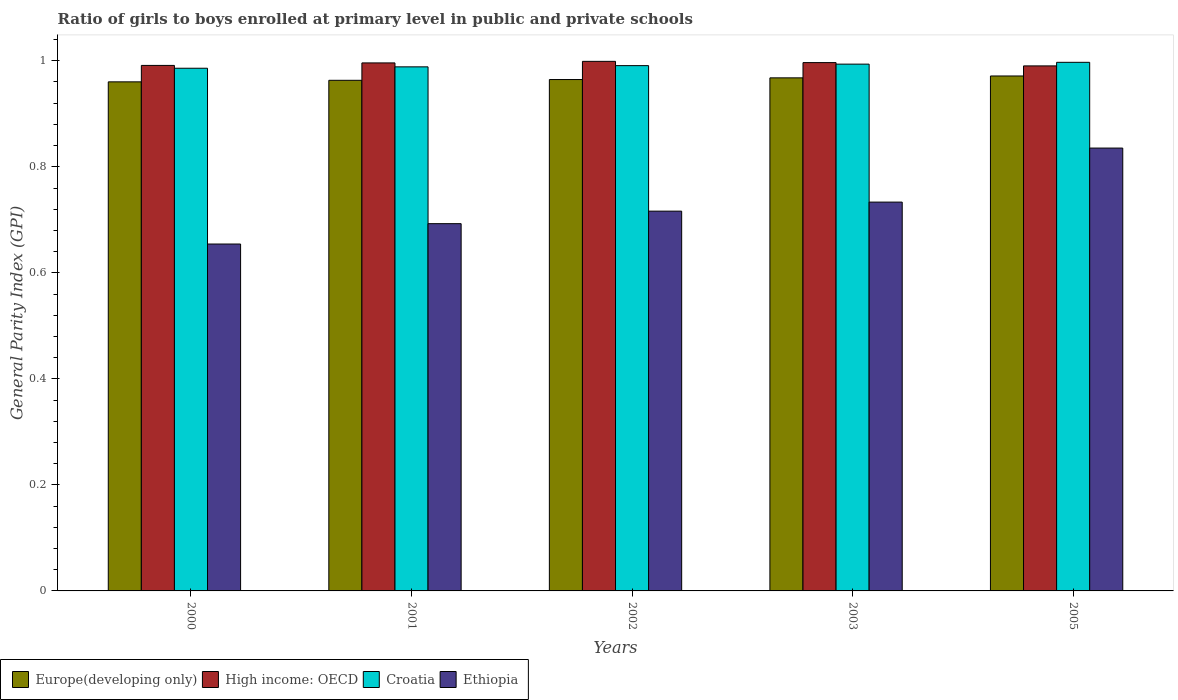Are the number of bars per tick equal to the number of legend labels?
Make the answer very short. Yes. What is the general parity index in Europe(developing only) in 2005?
Your answer should be compact. 0.97. Across all years, what is the maximum general parity index in High income: OECD?
Provide a succinct answer. 1. Across all years, what is the minimum general parity index in Croatia?
Your response must be concise. 0.99. What is the total general parity index in Europe(developing only) in the graph?
Provide a succinct answer. 4.83. What is the difference between the general parity index in Ethiopia in 2001 and that in 2002?
Your answer should be very brief. -0.02. What is the difference between the general parity index in High income: OECD in 2003 and the general parity index in Europe(developing only) in 2002?
Give a very brief answer. 0.03. What is the average general parity index in Ethiopia per year?
Offer a very short reply. 0.73. In the year 2001, what is the difference between the general parity index in Ethiopia and general parity index in High income: OECD?
Your answer should be compact. -0.3. What is the ratio of the general parity index in High income: OECD in 2001 to that in 2003?
Make the answer very short. 1. Is the general parity index in Croatia in 2000 less than that in 2002?
Ensure brevity in your answer.  Yes. What is the difference between the highest and the second highest general parity index in Croatia?
Offer a very short reply. 0. What is the difference between the highest and the lowest general parity index in Europe(developing only)?
Keep it short and to the point. 0.01. In how many years, is the general parity index in Ethiopia greater than the average general parity index in Ethiopia taken over all years?
Provide a short and direct response. 2. Is it the case that in every year, the sum of the general parity index in High income: OECD and general parity index in Europe(developing only) is greater than the sum of general parity index in Croatia and general parity index in Ethiopia?
Your answer should be very brief. No. What does the 1st bar from the left in 2002 represents?
Give a very brief answer. Europe(developing only). What does the 2nd bar from the right in 2005 represents?
Give a very brief answer. Croatia. How many bars are there?
Your response must be concise. 20. Are all the bars in the graph horizontal?
Offer a terse response. No. How many years are there in the graph?
Provide a short and direct response. 5. What is the difference between two consecutive major ticks on the Y-axis?
Ensure brevity in your answer.  0.2. Does the graph contain any zero values?
Keep it short and to the point. No. Does the graph contain grids?
Ensure brevity in your answer.  No. How many legend labels are there?
Your answer should be compact. 4. How are the legend labels stacked?
Your answer should be very brief. Horizontal. What is the title of the graph?
Your response must be concise. Ratio of girls to boys enrolled at primary level in public and private schools. What is the label or title of the X-axis?
Ensure brevity in your answer.  Years. What is the label or title of the Y-axis?
Offer a very short reply. General Parity Index (GPI). What is the General Parity Index (GPI) of Europe(developing only) in 2000?
Offer a very short reply. 0.96. What is the General Parity Index (GPI) of High income: OECD in 2000?
Provide a short and direct response. 0.99. What is the General Parity Index (GPI) in Croatia in 2000?
Give a very brief answer. 0.99. What is the General Parity Index (GPI) in Ethiopia in 2000?
Your response must be concise. 0.65. What is the General Parity Index (GPI) in Europe(developing only) in 2001?
Provide a short and direct response. 0.96. What is the General Parity Index (GPI) of High income: OECD in 2001?
Offer a very short reply. 1. What is the General Parity Index (GPI) in Croatia in 2001?
Your answer should be compact. 0.99. What is the General Parity Index (GPI) in Ethiopia in 2001?
Provide a succinct answer. 0.69. What is the General Parity Index (GPI) in Europe(developing only) in 2002?
Your answer should be very brief. 0.96. What is the General Parity Index (GPI) in High income: OECD in 2002?
Give a very brief answer. 1. What is the General Parity Index (GPI) in Croatia in 2002?
Provide a short and direct response. 0.99. What is the General Parity Index (GPI) in Ethiopia in 2002?
Keep it short and to the point. 0.72. What is the General Parity Index (GPI) of Europe(developing only) in 2003?
Make the answer very short. 0.97. What is the General Parity Index (GPI) of High income: OECD in 2003?
Keep it short and to the point. 1. What is the General Parity Index (GPI) in Croatia in 2003?
Offer a very short reply. 0.99. What is the General Parity Index (GPI) of Ethiopia in 2003?
Offer a very short reply. 0.73. What is the General Parity Index (GPI) of Europe(developing only) in 2005?
Offer a terse response. 0.97. What is the General Parity Index (GPI) in High income: OECD in 2005?
Provide a succinct answer. 0.99. What is the General Parity Index (GPI) of Croatia in 2005?
Offer a terse response. 1. What is the General Parity Index (GPI) of Ethiopia in 2005?
Keep it short and to the point. 0.84. Across all years, what is the maximum General Parity Index (GPI) in Europe(developing only)?
Your response must be concise. 0.97. Across all years, what is the maximum General Parity Index (GPI) in High income: OECD?
Offer a terse response. 1. Across all years, what is the maximum General Parity Index (GPI) in Croatia?
Provide a succinct answer. 1. Across all years, what is the maximum General Parity Index (GPI) of Ethiopia?
Provide a short and direct response. 0.84. Across all years, what is the minimum General Parity Index (GPI) in Europe(developing only)?
Your answer should be very brief. 0.96. Across all years, what is the minimum General Parity Index (GPI) in High income: OECD?
Provide a succinct answer. 0.99. Across all years, what is the minimum General Parity Index (GPI) of Croatia?
Offer a terse response. 0.99. Across all years, what is the minimum General Parity Index (GPI) of Ethiopia?
Offer a very short reply. 0.65. What is the total General Parity Index (GPI) in Europe(developing only) in the graph?
Provide a short and direct response. 4.83. What is the total General Parity Index (GPI) of High income: OECD in the graph?
Your answer should be very brief. 4.97. What is the total General Parity Index (GPI) in Croatia in the graph?
Your response must be concise. 4.96. What is the total General Parity Index (GPI) in Ethiopia in the graph?
Ensure brevity in your answer.  3.63. What is the difference between the General Parity Index (GPI) in Europe(developing only) in 2000 and that in 2001?
Your response must be concise. -0. What is the difference between the General Parity Index (GPI) of High income: OECD in 2000 and that in 2001?
Your answer should be very brief. -0. What is the difference between the General Parity Index (GPI) in Croatia in 2000 and that in 2001?
Provide a succinct answer. -0. What is the difference between the General Parity Index (GPI) of Ethiopia in 2000 and that in 2001?
Provide a succinct answer. -0.04. What is the difference between the General Parity Index (GPI) of Europe(developing only) in 2000 and that in 2002?
Make the answer very short. -0. What is the difference between the General Parity Index (GPI) in High income: OECD in 2000 and that in 2002?
Make the answer very short. -0.01. What is the difference between the General Parity Index (GPI) of Croatia in 2000 and that in 2002?
Your answer should be compact. -0. What is the difference between the General Parity Index (GPI) in Ethiopia in 2000 and that in 2002?
Make the answer very short. -0.06. What is the difference between the General Parity Index (GPI) in Europe(developing only) in 2000 and that in 2003?
Make the answer very short. -0.01. What is the difference between the General Parity Index (GPI) in High income: OECD in 2000 and that in 2003?
Provide a short and direct response. -0.01. What is the difference between the General Parity Index (GPI) in Croatia in 2000 and that in 2003?
Ensure brevity in your answer.  -0.01. What is the difference between the General Parity Index (GPI) in Ethiopia in 2000 and that in 2003?
Your answer should be very brief. -0.08. What is the difference between the General Parity Index (GPI) of Europe(developing only) in 2000 and that in 2005?
Keep it short and to the point. -0.01. What is the difference between the General Parity Index (GPI) in High income: OECD in 2000 and that in 2005?
Your response must be concise. 0. What is the difference between the General Parity Index (GPI) of Croatia in 2000 and that in 2005?
Ensure brevity in your answer.  -0.01. What is the difference between the General Parity Index (GPI) of Ethiopia in 2000 and that in 2005?
Ensure brevity in your answer.  -0.18. What is the difference between the General Parity Index (GPI) of Europe(developing only) in 2001 and that in 2002?
Offer a very short reply. -0. What is the difference between the General Parity Index (GPI) of High income: OECD in 2001 and that in 2002?
Your response must be concise. -0. What is the difference between the General Parity Index (GPI) of Croatia in 2001 and that in 2002?
Provide a succinct answer. -0. What is the difference between the General Parity Index (GPI) in Ethiopia in 2001 and that in 2002?
Ensure brevity in your answer.  -0.02. What is the difference between the General Parity Index (GPI) of Europe(developing only) in 2001 and that in 2003?
Offer a terse response. -0. What is the difference between the General Parity Index (GPI) in High income: OECD in 2001 and that in 2003?
Offer a terse response. -0. What is the difference between the General Parity Index (GPI) in Croatia in 2001 and that in 2003?
Offer a very short reply. -0.01. What is the difference between the General Parity Index (GPI) of Ethiopia in 2001 and that in 2003?
Your answer should be very brief. -0.04. What is the difference between the General Parity Index (GPI) of Europe(developing only) in 2001 and that in 2005?
Keep it short and to the point. -0.01. What is the difference between the General Parity Index (GPI) in High income: OECD in 2001 and that in 2005?
Make the answer very short. 0.01. What is the difference between the General Parity Index (GPI) in Croatia in 2001 and that in 2005?
Offer a terse response. -0.01. What is the difference between the General Parity Index (GPI) of Ethiopia in 2001 and that in 2005?
Keep it short and to the point. -0.14. What is the difference between the General Parity Index (GPI) of Europe(developing only) in 2002 and that in 2003?
Ensure brevity in your answer.  -0. What is the difference between the General Parity Index (GPI) in High income: OECD in 2002 and that in 2003?
Your answer should be compact. 0. What is the difference between the General Parity Index (GPI) of Croatia in 2002 and that in 2003?
Offer a terse response. -0. What is the difference between the General Parity Index (GPI) of Ethiopia in 2002 and that in 2003?
Offer a very short reply. -0.02. What is the difference between the General Parity Index (GPI) of Europe(developing only) in 2002 and that in 2005?
Offer a very short reply. -0.01. What is the difference between the General Parity Index (GPI) of High income: OECD in 2002 and that in 2005?
Provide a succinct answer. 0.01. What is the difference between the General Parity Index (GPI) of Croatia in 2002 and that in 2005?
Your answer should be compact. -0.01. What is the difference between the General Parity Index (GPI) of Ethiopia in 2002 and that in 2005?
Keep it short and to the point. -0.12. What is the difference between the General Parity Index (GPI) in Europe(developing only) in 2003 and that in 2005?
Offer a terse response. -0. What is the difference between the General Parity Index (GPI) in High income: OECD in 2003 and that in 2005?
Offer a very short reply. 0.01. What is the difference between the General Parity Index (GPI) in Croatia in 2003 and that in 2005?
Your answer should be very brief. -0. What is the difference between the General Parity Index (GPI) in Ethiopia in 2003 and that in 2005?
Keep it short and to the point. -0.1. What is the difference between the General Parity Index (GPI) in Europe(developing only) in 2000 and the General Parity Index (GPI) in High income: OECD in 2001?
Ensure brevity in your answer.  -0.04. What is the difference between the General Parity Index (GPI) of Europe(developing only) in 2000 and the General Parity Index (GPI) of Croatia in 2001?
Your answer should be very brief. -0.03. What is the difference between the General Parity Index (GPI) in Europe(developing only) in 2000 and the General Parity Index (GPI) in Ethiopia in 2001?
Provide a short and direct response. 0.27. What is the difference between the General Parity Index (GPI) of High income: OECD in 2000 and the General Parity Index (GPI) of Croatia in 2001?
Offer a very short reply. 0. What is the difference between the General Parity Index (GPI) of High income: OECD in 2000 and the General Parity Index (GPI) of Ethiopia in 2001?
Provide a succinct answer. 0.3. What is the difference between the General Parity Index (GPI) in Croatia in 2000 and the General Parity Index (GPI) in Ethiopia in 2001?
Provide a succinct answer. 0.29. What is the difference between the General Parity Index (GPI) in Europe(developing only) in 2000 and the General Parity Index (GPI) in High income: OECD in 2002?
Give a very brief answer. -0.04. What is the difference between the General Parity Index (GPI) of Europe(developing only) in 2000 and the General Parity Index (GPI) of Croatia in 2002?
Your response must be concise. -0.03. What is the difference between the General Parity Index (GPI) in Europe(developing only) in 2000 and the General Parity Index (GPI) in Ethiopia in 2002?
Offer a terse response. 0.24. What is the difference between the General Parity Index (GPI) in High income: OECD in 2000 and the General Parity Index (GPI) in Croatia in 2002?
Ensure brevity in your answer.  0. What is the difference between the General Parity Index (GPI) of High income: OECD in 2000 and the General Parity Index (GPI) of Ethiopia in 2002?
Provide a short and direct response. 0.27. What is the difference between the General Parity Index (GPI) in Croatia in 2000 and the General Parity Index (GPI) in Ethiopia in 2002?
Your response must be concise. 0.27. What is the difference between the General Parity Index (GPI) of Europe(developing only) in 2000 and the General Parity Index (GPI) of High income: OECD in 2003?
Provide a short and direct response. -0.04. What is the difference between the General Parity Index (GPI) in Europe(developing only) in 2000 and the General Parity Index (GPI) in Croatia in 2003?
Your response must be concise. -0.03. What is the difference between the General Parity Index (GPI) of Europe(developing only) in 2000 and the General Parity Index (GPI) of Ethiopia in 2003?
Provide a succinct answer. 0.23. What is the difference between the General Parity Index (GPI) in High income: OECD in 2000 and the General Parity Index (GPI) in Croatia in 2003?
Make the answer very short. -0. What is the difference between the General Parity Index (GPI) of High income: OECD in 2000 and the General Parity Index (GPI) of Ethiopia in 2003?
Your response must be concise. 0.26. What is the difference between the General Parity Index (GPI) of Croatia in 2000 and the General Parity Index (GPI) of Ethiopia in 2003?
Provide a succinct answer. 0.25. What is the difference between the General Parity Index (GPI) in Europe(developing only) in 2000 and the General Parity Index (GPI) in High income: OECD in 2005?
Make the answer very short. -0.03. What is the difference between the General Parity Index (GPI) in Europe(developing only) in 2000 and the General Parity Index (GPI) in Croatia in 2005?
Your response must be concise. -0.04. What is the difference between the General Parity Index (GPI) in Europe(developing only) in 2000 and the General Parity Index (GPI) in Ethiopia in 2005?
Your response must be concise. 0.12. What is the difference between the General Parity Index (GPI) in High income: OECD in 2000 and the General Parity Index (GPI) in Croatia in 2005?
Provide a succinct answer. -0.01. What is the difference between the General Parity Index (GPI) of High income: OECD in 2000 and the General Parity Index (GPI) of Ethiopia in 2005?
Keep it short and to the point. 0.16. What is the difference between the General Parity Index (GPI) of Croatia in 2000 and the General Parity Index (GPI) of Ethiopia in 2005?
Provide a succinct answer. 0.15. What is the difference between the General Parity Index (GPI) in Europe(developing only) in 2001 and the General Parity Index (GPI) in High income: OECD in 2002?
Your answer should be very brief. -0.04. What is the difference between the General Parity Index (GPI) of Europe(developing only) in 2001 and the General Parity Index (GPI) of Croatia in 2002?
Your response must be concise. -0.03. What is the difference between the General Parity Index (GPI) in Europe(developing only) in 2001 and the General Parity Index (GPI) in Ethiopia in 2002?
Provide a short and direct response. 0.25. What is the difference between the General Parity Index (GPI) of High income: OECD in 2001 and the General Parity Index (GPI) of Croatia in 2002?
Provide a short and direct response. 0.01. What is the difference between the General Parity Index (GPI) in High income: OECD in 2001 and the General Parity Index (GPI) in Ethiopia in 2002?
Ensure brevity in your answer.  0.28. What is the difference between the General Parity Index (GPI) in Croatia in 2001 and the General Parity Index (GPI) in Ethiopia in 2002?
Ensure brevity in your answer.  0.27. What is the difference between the General Parity Index (GPI) in Europe(developing only) in 2001 and the General Parity Index (GPI) in High income: OECD in 2003?
Your answer should be very brief. -0.03. What is the difference between the General Parity Index (GPI) in Europe(developing only) in 2001 and the General Parity Index (GPI) in Croatia in 2003?
Offer a very short reply. -0.03. What is the difference between the General Parity Index (GPI) in Europe(developing only) in 2001 and the General Parity Index (GPI) in Ethiopia in 2003?
Provide a short and direct response. 0.23. What is the difference between the General Parity Index (GPI) of High income: OECD in 2001 and the General Parity Index (GPI) of Croatia in 2003?
Keep it short and to the point. 0. What is the difference between the General Parity Index (GPI) in High income: OECD in 2001 and the General Parity Index (GPI) in Ethiopia in 2003?
Give a very brief answer. 0.26. What is the difference between the General Parity Index (GPI) of Croatia in 2001 and the General Parity Index (GPI) of Ethiopia in 2003?
Give a very brief answer. 0.26. What is the difference between the General Parity Index (GPI) of Europe(developing only) in 2001 and the General Parity Index (GPI) of High income: OECD in 2005?
Your response must be concise. -0.03. What is the difference between the General Parity Index (GPI) in Europe(developing only) in 2001 and the General Parity Index (GPI) in Croatia in 2005?
Provide a succinct answer. -0.03. What is the difference between the General Parity Index (GPI) in Europe(developing only) in 2001 and the General Parity Index (GPI) in Ethiopia in 2005?
Keep it short and to the point. 0.13. What is the difference between the General Parity Index (GPI) in High income: OECD in 2001 and the General Parity Index (GPI) in Croatia in 2005?
Your answer should be very brief. -0. What is the difference between the General Parity Index (GPI) in High income: OECD in 2001 and the General Parity Index (GPI) in Ethiopia in 2005?
Offer a terse response. 0.16. What is the difference between the General Parity Index (GPI) in Croatia in 2001 and the General Parity Index (GPI) in Ethiopia in 2005?
Keep it short and to the point. 0.15. What is the difference between the General Parity Index (GPI) in Europe(developing only) in 2002 and the General Parity Index (GPI) in High income: OECD in 2003?
Your answer should be compact. -0.03. What is the difference between the General Parity Index (GPI) in Europe(developing only) in 2002 and the General Parity Index (GPI) in Croatia in 2003?
Make the answer very short. -0.03. What is the difference between the General Parity Index (GPI) in Europe(developing only) in 2002 and the General Parity Index (GPI) in Ethiopia in 2003?
Your answer should be compact. 0.23. What is the difference between the General Parity Index (GPI) of High income: OECD in 2002 and the General Parity Index (GPI) of Croatia in 2003?
Give a very brief answer. 0.01. What is the difference between the General Parity Index (GPI) in High income: OECD in 2002 and the General Parity Index (GPI) in Ethiopia in 2003?
Provide a short and direct response. 0.27. What is the difference between the General Parity Index (GPI) in Croatia in 2002 and the General Parity Index (GPI) in Ethiopia in 2003?
Give a very brief answer. 0.26. What is the difference between the General Parity Index (GPI) of Europe(developing only) in 2002 and the General Parity Index (GPI) of High income: OECD in 2005?
Ensure brevity in your answer.  -0.03. What is the difference between the General Parity Index (GPI) of Europe(developing only) in 2002 and the General Parity Index (GPI) of Croatia in 2005?
Make the answer very short. -0.03. What is the difference between the General Parity Index (GPI) in Europe(developing only) in 2002 and the General Parity Index (GPI) in Ethiopia in 2005?
Give a very brief answer. 0.13. What is the difference between the General Parity Index (GPI) of High income: OECD in 2002 and the General Parity Index (GPI) of Croatia in 2005?
Provide a short and direct response. 0. What is the difference between the General Parity Index (GPI) of High income: OECD in 2002 and the General Parity Index (GPI) of Ethiopia in 2005?
Your answer should be compact. 0.16. What is the difference between the General Parity Index (GPI) in Croatia in 2002 and the General Parity Index (GPI) in Ethiopia in 2005?
Ensure brevity in your answer.  0.16. What is the difference between the General Parity Index (GPI) of Europe(developing only) in 2003 and the General Parity Index (GPI) of High income: OECD in 2005?
Your response must be concise. -0.02. What is the difference between the General Parity Index (GPI) in Europe(developing only) in 2003 and the General Parity Index (GPI) in Croatia in 2005?
Make the answer very short. -0.03. What is the difference between the General Parity Index (GPI) in Europe(developing only) in 2003 and the General Parity Index (GPI) in Ethiopia in 2005?
Offer a terse response. 0.13. What is the difference between the General Parity Index (GPI) of High income: OECD in 2003 and the General Parity Index (GPI) of Croatia in 2005?
Your response must be concise. -0. What is the difference between the General Parity Index (GPI) of High income: OECD in 2003 and the General Parity Index (GPI) of Ethiopia in 2005?
Your answer should be very brief. 0.16. What is the difference between the General Parity Index (GPI) in Croatia in 2003 and the General Parity Index (GPI) in Ethiopia in 2005?
Offer a terse response. 0.16. What is the average General Parity Index (GPI) in Europe(developing only) per year?
Ensure brevity in your answer.  0.97. What is the average General Parity Index (GPI) in High income: OECD per year?
Ensure brevity in your answer.  0.99. What is the average General Parity Index (GPI) of Croatia per year?
Keep it short and to the point. 0.99. What is the average General Parity Index (GPI) in Ethiopia per year?
Provide a short and direct response. 0.73. In the year 2000, what is the difference between the General Parity Index (GPI) in Europe(developing only) and General Parity Index (GPI) in High income: OECD?
Your answer should be compact. -0.03. In the year 2000, what is the difference between the General Parity Index (GPI) in Europe(developing only) and General Parity Index (GPI) in Croatia?
Offer a very short reply. -0.03. In the year 2000, what is the difference between the General Parity Index (GPI) of Europe(developing only) and General Parity Index (GPI) of Ethiopia?
Your response must be concise. 0.31. In the year 2000, what is the difference between the General Parity Index (GPI) in High income: OECD and General Parity Index (GPI) in Croatia?
Provide a short and direct response. 0.01. In the year 2000, what is the difference between the General Parity Index (GPI) of High income: OECD and General Parity Index (GPI) of Ethiopia?
Offer a very short reply. 0.34. In the year 2000, what is the difference between the General Parity Index (GPI) in Croatia and General Parity Index (GPI) in Ethiopia?
Provide a short and direct response. 0.33. In the year 2001, what is the difference between the General Parity Index (GPI) in Europe(developing only) and General Parity Index (GPI) in High income: OECD?
Provide a short and direct response. -0.03. In the year 2001, what is the difference between the General Parity Index (GPI) in Europe(developing only) and General Parity Index (GPI) in Croatia?
Your response must be concise. -0.03. In the year 2001, what is the difference between the General Parity Index (GPI) of Europe(developing only) and General Parity Index (GPI) of Ethiopia?
Give a very brief answer. 0.27. In the year 2001, what is the difference between the General Parity Index (GPI) of High income: OECD and General Parity Index (GPI) of Croatia?
Offer a terse response. 0.01. In the year 2001, what is the difference between the General Parity Index (GPI) of High income: OECD and General Parity Index (GPI) of Ethiopia?
Your answer should be compact. 0.3. In the year 2001, what is the difference between the General Parity Index (GPI) of Croatia and General Parity Index (GPI) of Ethiopia?
Ensure brevity in your answer.  0.3. In the year 2002, what is the difference between the General Parity Index (GPI) of Europe(developing only) and General Parity Index (GPI) of High income: OECD?
Your answer should be very brief. -0.03. In the year 2002, what is the difference between the General Parity Index (GPI) of Europe(developing only) and General Parity Index (GPI) of Croatia?
Ensure brevity in your answer.  -0.03. In the year 2002, what is the difference between the General Parity Index (GPI) in Europe(developing only) and General Parity Index (GPI) in Ethiopia?
Provide a short and direct response. 0.25. In the year 2002, what is the difference between the General Parity Index (GPI) of High income: OECD and General Parity Index (GPI) of Croatia?
Make the answer very short. 0.01. In the year 2002, what is the difference between the General Parity Index (GPI) in High income: OECD and General Parity Index (GPI) in Ethiopia?
Ensure brevity in your answer.  0.28. In the year 2002, what is the difference between the General Parity Index (GPI) in Croatia and General Parity Index (GPI) in Ethiopia?
Ensure brevity in your answer.  0.27. In the year 2003, what is the difference between the General Parity Index (GPI) of Europe(developing only) and General Parity Index (GPI) of High income: OECD?
Offer a terse response. -0.03. In the year 2003, what is the difference between the General Parity Index (GPI) in Europe(developing only) and General Parity Index (GPI) in Croatia?
Your answer should be compact. -0.03. In the year 2003, what is the difference between the General Parity Index (GPI) of Europe(developing only) and General Parity Index (GPI) of Ethiopia?
Ensure brevity in your answer.  0.23. In the year 2003, what is the difference between the General Parity Index (GPI) in High income: OECD and General Parity Index (GPI) in Croatia?
Your answer should be compact. 0. In the year 2003, what is the difference between the General Parity Index (GPI) of High income: OECD and General Parity Index (GPI) of Ethiopia?
Provide a succinct answer. 0.26. In the year 2003, what is the difference between the General Parity Index (GPI) in Croatia and General Parity Index (GPI) in Ethiopia?
Offer a terse response. 0.26. In the year 2005, what is the difference between the General Parity Index (GPI) of Europe(developing only) and General Parity Index (GPI) of High income: OECD?
Your response must be concise. -0.02. In the year 2005, what is the difference between the General Parity Index (GPI) of Europe(developing only) and General Parity Index (GPI) of Croatia?
Your response must be concise. -0.03. In the year 2005, what is the difference between the General Parity Index (GPI) in Europe(developing only) and General Parity Index (GPI) in Ethiopia?
Offer a terse response. 0.14. In the year 2005, what is the difference between the General Parity Index (GPI) of High income: OECD and General Parity Index (GPI) of Croatia?
Your answer should be very brief. -0.01. In the year 2005, what is the difference between the General Parity Index (GPI) of High income: OECD and General Parity Index (GPI) of Ethiopia?
Offer a terse response. 0.15. In the year 2005, what is the difference between the General Parity Index (GPI) in Croatia and General Parity Index (GPI) in Ethiopia?
Your answer should be compact. 0.16. What is the ratio of the General Parity Index (GPI) of High income: OECD in 2000 to that in 2001?
Provide a succinct answer. 1. What is the ratio of the General Parity Index (GPI) of Croatia in 2000 to that in 2001?
Offer a terse response. 1. What is the ratio of the General Parity Index (GPI) in Ethiopia in 2000 to that in 2001?
Give a very brief answer. 0.94. What is the ratio of the General Parity Index (GPI) in Europe(developing only) in 2000 to that in 2002?
Your answer should be compact. 1. What is the ratio of the General Parity Index (GPI) of High income: OECD in 2000 to that in 2002?
Ensure brevity in your answer.  0.99. What is the ratio of the General Parity Index (GPI) of Ethiopia in 2000 to that in 2002?
Offer a terse response. 0.91. What is the ratio of the General Parity Index (GPI) in Croatia in 2000 to that in 2003?
Ensure brevity in your answer.  0.99. What is the ratio of the General Parity Index (GPI) in Ethiopia in 2000 to that in 2003?
Your answer should be very brief. 0.89. What is the ratio of the General Parity Index (GPI) in High income: OECD in 2000 to that in 2005?
Your answer should be very brief. 1. What is the ratio of the General Parity Index (GPI) of Croatia in 2000 to that in 2005?
Your answer should be very brief. 0.99. What is the ratio of the General Parity Index (GPI) in Ethiopia in 2000 to that in 2005?
Provide a succinct answer. 0.78. What is the ratio of the General Parity Index (GPI) in Europe(developing only) in 2001 to that in 2002?
Your response must be concise. 1. What is the ratio of the General Parity Index (GPI) of Croatia in 2001 to that in 2002?
Provide a succinct answer. 1. What is the ratio of the General Parity Index (GPI) in Ethiopia in 2001 to that in 2002?
Offer a very short reply. 0.97. What is the ratio of the General Parity Index (GPI) of High income: OECD in 2001 to that in 2003?
Give a very brief answer. 1. What is the ratio of the General Parity Index (GPI) in Ethiopia in 2001 to that in 2003?
Make the answer very short. 0.94. What is the ratio of the General Parity Index (GPI) in Europe(developing only) in 2001 to that in 2005?
Keep it short and to the point. 0.99. What is the ratio of the General Parity Index (GPI) in Ethiopia in 2001 to that in 2005?
Your answer should be very brief. 0.83. What is the ratio of the General Parity Index (GPI) in Ethiopia in 2002 to that in 2003?
Your response must be concise. 0.98. What is the ratio of the General Parity Index (GPI) in High income: OECD in 2002 to that in 2005?
Your response must be concise. 1.01. What is the ratio of the General Parity Index (GPI) in Ethiopia in 2002 to that in 2005?
Your answer should be compact. 0.86. What is the ratio of the General Parity Index (GPI) in Europe(developing only) in 2003 to that in 2005?
Keep it short and to the point. 1. What is the ratio of the General Parity Index (GPI) of High income: OECD in 2003 to that in 2005?
Provide a succinct answer. 1.01. What is the ratio of the General Parity Index (GPI) of Croatia in 2003 to that in 2005?
Your answer should be compact. 1. What is the ratio of the General Parity Index (GPI) in Ethiopia in 2003 to that in 2005?
Make the answer very short. 0.88. What is the difference between the highest and the second highest General Parity Index (GPI) of Europe(developing only)?
Offer a terse response. 0. What is the difference between the highest and the second highest General Parity Index (GPI) in High income: OECD?
Offer a terse response. 0. What is the difference between the highest and the second highest General Parity Index (GPI) in Croatia?
Your response must be concise. 0. What is the difference between the highest and the second highest General Parity Index (GPI) of Ethiopia?
Offer a terse response. 0.1. What is the difference between the highest and the lowest General Parity Index (GPI) of Europe(developing only)?
Provide a succinct answer. 0.01. What is the difference between the highest and the lowest General Parity Index (GPI) of High income: OECD?
Provide a succinct answer. 0.01. What is the difference between the highest and the lowest General Parity Index (GPI) in Croatia?
Provide a short and direct response. 0.01. What is the difference between the highest and the lowest General Parity Index (GPI) of Ethiopia?
Offer a terse response. 0.18. 